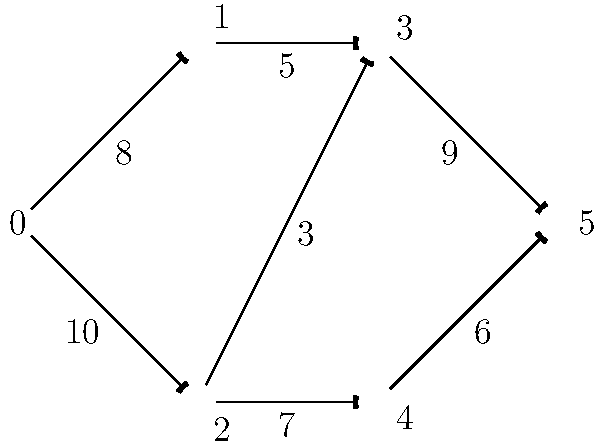As a fellow rower, you and Rohan are discussing the flow of boats through a series of locks on a river. The network of locks is represented by the graph above, where each edge represents a lock with its capacity (maximum number of boats that can pass through per hour). What is the maximum number of boats that can pass from lock 0 to lock 5 per hour? To solve this maximum flow problem, we can use the Ford-Fulkerson algorithm:

1) Identify source (0) and sink (5) vertices.

2) Find augmenting paths and their bottleneck capacities:
   Path 1: 0 -> 1 -> 3 -> 5 (bottleneck = 5)
   Path 2: 0 -> 2 -> 3 -> 5 (bottleneck = 3)
   Path 3: 0 -> 2 -> 4 -> 5 (bottleneck = 6)

3) Calculate total flow:
   5 + 3 + 6 = 14

4) Verify no more augmenting paths exist:
   - Edge (0,1) has 3 capacity left, but (1,3) is full
   - Edge (0,2) has 1 capacity left, but (2,3) and (2,4) are full
   - No path from 0 to 5 remains

Therefore, the maximum flow from lock 0 to lock 5 is 14 boats per hour.
Answer: 14 boats per hour 